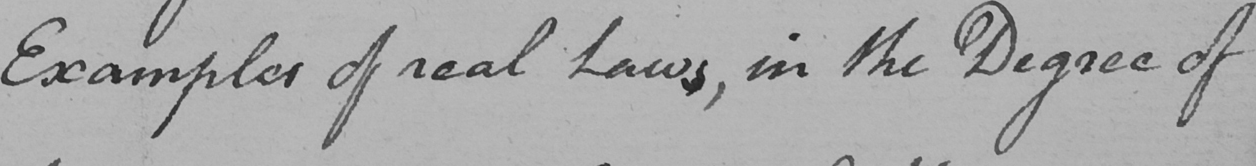Transcribe the text shown in this historical manuscript line. Examples of real Laws , in the Degree of 